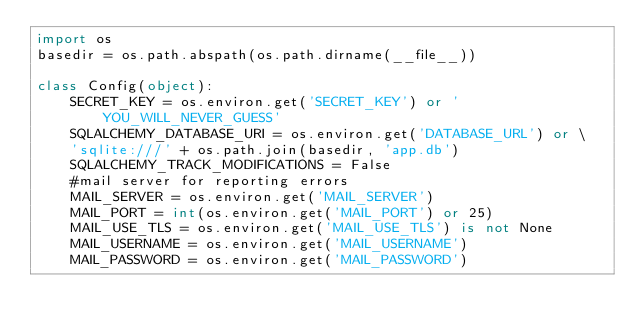Convert code to text. <code><loc_0><loc_0><loc_500><loc_500><_Python_>import os
basedir = os.path.abspath(os.path.dirname(__file__))

class Config(object):
    SECRET_KEY = os.environ.get('SECRET_KEY') or 'YOU_WILL_NEVER_GUESS'
    SQLALCHEMY_DATABASE_URI = os.environ.get('DATABASE_URL') or \
    'sqlite:///' + os.path.join(basedir, 'app.db')
    SQLALCHEMY_TRACK_MODIFICATIONS = False
    #mail server for reporting errors
    MAIL_SERVER = os.environ.get('MAIL_SERVER')
    MAIL_PORT = int(os.environ.get('MAIL_PORT') or 25)
    MAIL_USE_TLS = os.environ.get('MAIL_USE_TLS') is not None
    MAIL_USERNAME = os.environ.get('MAIL_USERNAME')
    MAIL_PASSWORD = os.environ.get('MAIL_PASSWORD')</code> 